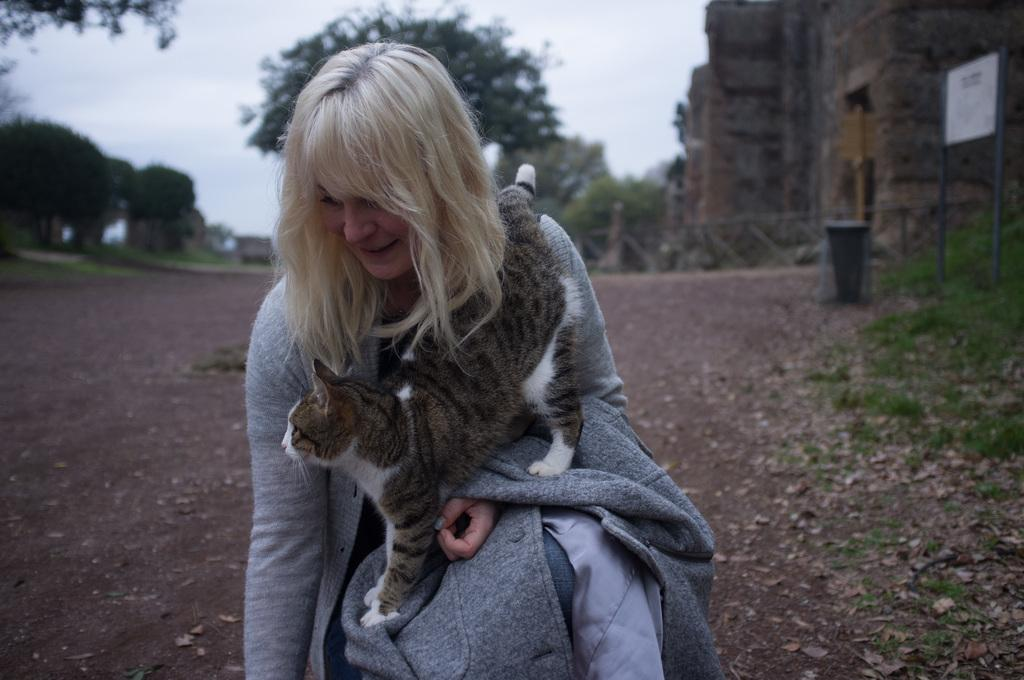Who is in the picture? There is a woman in the picture. What other living creature is present in the image? A cat is present in the picture. Can you describe the background of the image? The background includes land, trees, a building, and the sky. What type of clam is visible on the woman's shoulder in the image? There is no clam visible on the woman's shoulder in the image. Is there a box containing the woman's belongings in the image? There is no box containing the woman's belongings in the image. 